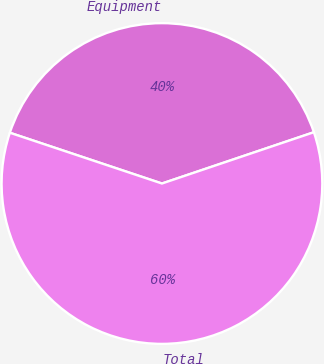<chart> <loc_0><loc_0><loc_500><loc_500><pie_chart><fcel>Equipment<fcel>Total<nl><fcel>39.69%<fcel>60.31%<nl></chart> 